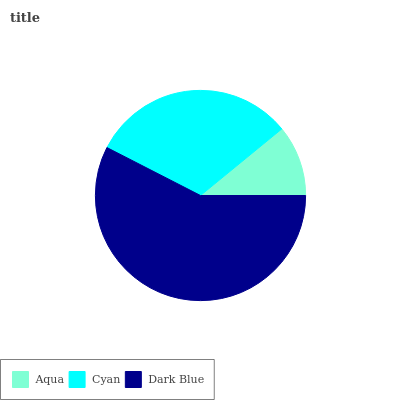Is Aqua the minimum?
Answer yes or no. Yes. Is Dark Blue the maximum?
Answer yes or no. Yes. Is Cyan the minimum?
Answer yes or no. No. Is Cyan the maximum?
Answer yes or no. No. Is Cyan greater than Aqua?
Answer yes or no. Yes. Is Aqua less than Cyan?
Answer yes or no. Yes. Is Aqua greater than Cyan?
Answer yes or no. No. Is Cyan less than Aqua?
Answer yes or no. No. Is Cyan the high median?
Answer yes or no. Yes. Is Cyan the low median?
Answer yes or no. Yes. Is Dark Blue the high median?
Answer yes or no. No. Is Aqua the low median?
Answer yes or no. No. 